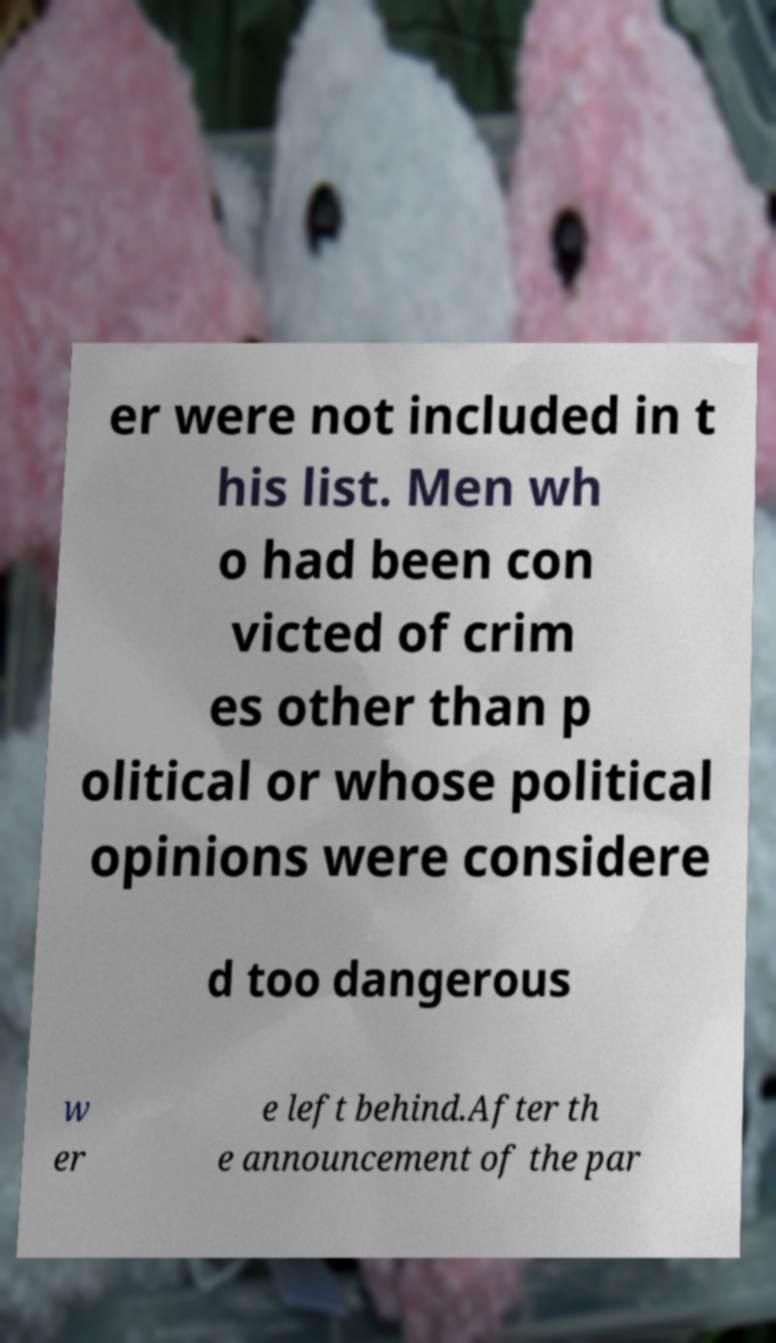Could you extract and type out the text from this image? er were not included in t his list. Men wh o had been con victed of crim es other than p olitical or whose political opinions were considere d too dangerous w er e left behind.After th e announcement of the par 